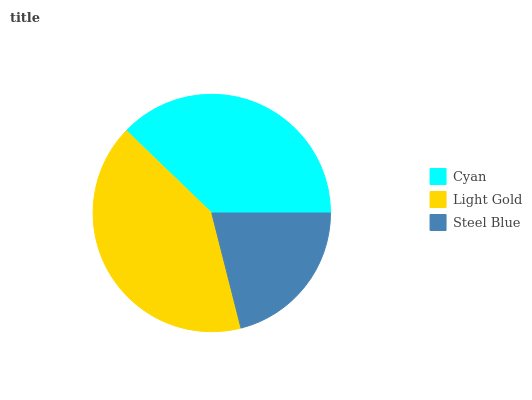Is Steel Blue the minimum?
Answer yes or no. Yes. Is Light Gold the maximum?
Answer yes or no. Yes. Is Light Gold the minimum?
Answer yes or no. No. Is Steel Blue the maximum?
Answer yes or no. No. Is Light Gold greater than Steel Blue?
Answer yes or no. Yes. Is Steel Blue less than Light Gold?
Answer yes or no. Yes. Is Steel Blue greater than Light Gold?
Answer yes or no. No. Is Light Gold less than Steel Blue?
Answer yes or no. No. Is Cyan the high median?
Answer yes or no. Yes. Is Cyan the low median?
Answer yes or no. Yes. Is Steel Blue the high median?
Answer yes or no. No. Is Steel Blue the low median?
Answer yes or no. No. 